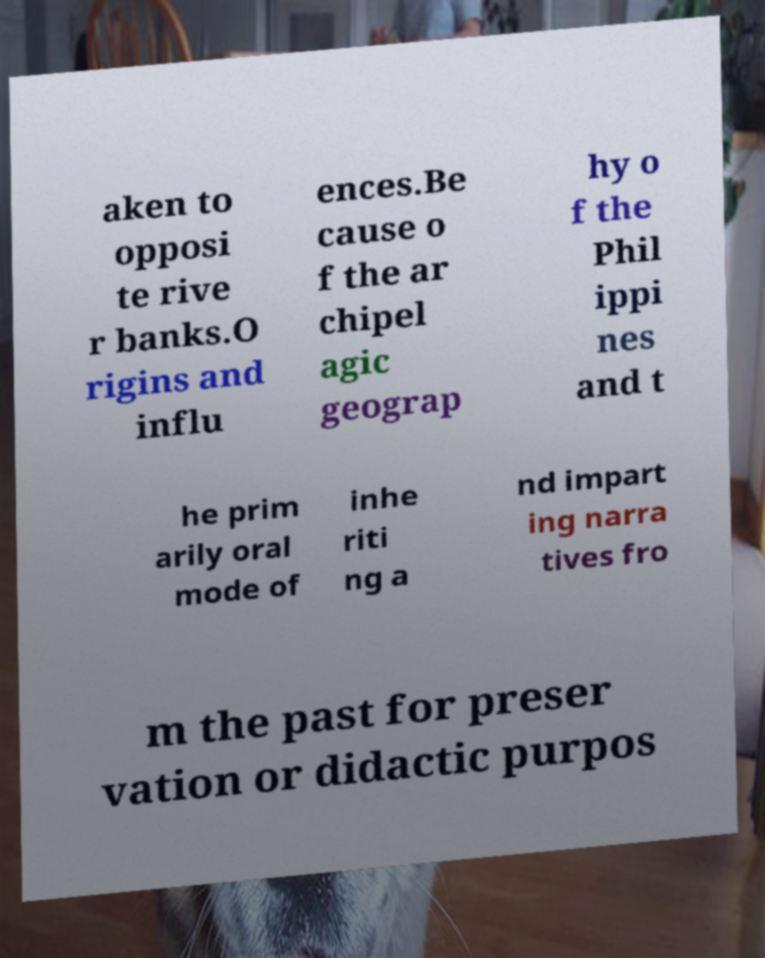Could you assist in decoding the text presented in this image and type it out clearly? aken to opposi te rive r banks.O rigins and influ ences.Be cause o f the ar chipel agic geograp hy o f the Phil ippi nes and t he prim arily oral mode of inhe riti ng a nd impart ing narra tives fro m the past for preser vation or didactic purpos 